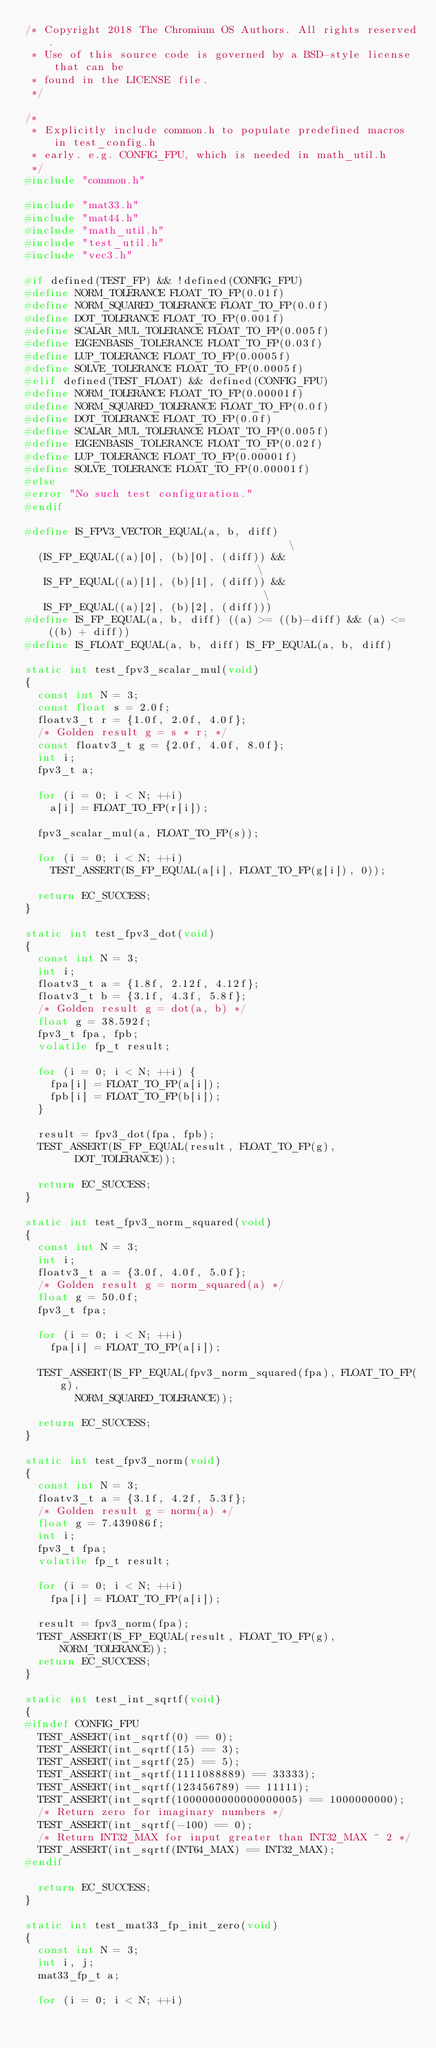Convert code to text. <code><loc_0><loc_0><loc_500><loc_500><_C_>/* Copyright 2018 The Chromium OS Authors. All rights reserved.
 * Use of this source code is governed by a BSD-style license that can be
 * found in the LICENSE file.
 */

/*
 * Explicitly include common.h to populate predefined macros in test_config.h
 * early. e.g. CONFIG_FPU, which is needed in math_util.h
 */
#include "common.h"

#include "mat33.h"
#include "mat44.h"
#include "math_util.h"
#include "test_util.h"
#include "vec3.h"

#if defined(TEST_FP) && !defined(CONFIG_FPU)
#define NORM_TOLERANCE FLOAT_TO_FP(0.01f)
#define NORM_SQUARED_TOLERANCE FLOAT_TO_FP(0.0f)
#define DOT_TOLERANCE FLOAT_TO_FP(0.001f)
#define SCALAR_MUL_TOLERANCE FLOAT_TO_FP(0.005f)
#define EIGENBASIS_TOLERANCE FLOAT_TO_FP(0.03f)
#define LUP_TOLERANCE FLOAT_TO_FP(0.0005f)
#define SOLVE_TOLERANCE FLOAT_TO_FP(0.0005f)
#elif defined(TEST_FLOAT) && defined(CONFIG_FPU)
#define NORM_TOLERANCE FLOAT_TO_FP(0.00001f)
#define NORM_SQUARED_TOLERANCE FLOAT_TO_FP(0.0f)
#define DOT_TOLERANCE FLOAT_TO_FP(0.0f)
#define SCALAR_MUL_TOLERANCE FLOAT_TO_FP(0.005f)
#define EIGENBASIS_TOLERANCE FLOAT_TO_FP(0.02f)
#define LUP_TOLERANCE FLOAT_TO_FP(0.00001f)
#define SOLVE_TOLERANCE FLOAT_TO_FP(0.00001f)
#else
#error "No such test configuration."
#endif

#define IS_FPV3_VECTOR_EQUAL(a, b, diff)                                       \
	(IS_FP_EQUAL((a)[0], (b)[0], (diff)) &&                                \
	 IS_FP_EQUAL((a)[1], (b)[1], (diff)) &&                                \
	 IS_FP_EQUAL((a)[2], (b)[2], (diff)))
#define IS_FP_EQUAL(a, b, diff) ((a) >= ((b)-diff) && (a) <= ((b) + diff))
#define IS_FLOAT_EQUAL(a, b, diff) IS_FP_EQUAL(a, b, diff)

static int test_fpv3_scalar_mul(void)
{
	const int N = 3;
	const float s = 2.0f;
	floatv3_t r = {1.0f, 2.0f, 4.0f};
	/* Golden result g = s * r; */
	const floatv3_t g = {2.0f, 4.0f, 8.0f};
	int i;
	fpv3_t a;

	for (i = 0; i < N; ++i)
		a[i] = FLOAT_TO_FP(r[i]);

	fpv3_scalar_mul(a, FLOAT_TO_FP(s));

	for (i = 0; i < N; ++i)
		TEST_ASSERT(IS_FP_EQUAL(a[i], FLOAT_TO_FP(g[i]), 0));

	return EC_SUCCESS;
}

static int test_fpv3_dot(void)
{
	const int N = 3;
	int i;
	floatv3_t a = {1.8f, 2.12f, 4.12f};
	floatv3_t b = {3.1f, 4.3f, 5.8f};
	/* Golden result g = dot(a, b) */
	float g = 38.592f;
	fpv3_t fpa, fpb;
	volatile fp_t result;

	for (i = 0; i < N; ++i) {
		fpa[i] = FLOAT_TO_FP(a[i]);
		fpb[i] = FLOAT_TO_FP(b[i]);
	}

	result = fpv3_dot(fpa, fpb);
	TEST_ASSERT(IS_FP_EQUAL(result, FLOAT_TO_FP(g),
				DOT_TOLERANCE));

	return EC_SUCCESS;
}

static int test_fpv3_norm_squared(void)
{
	const int N = 3;
	int i;
	floatv3_t a = {3.0f, 4.0f, 5.0f};
	/* Golden result g = norm_squared(a) */
	float g = 50.0f;
	fpv3_t fpa;

	for (i = 0; i < N; ++i)
		fpa[i] = FLOAT_TO_FP(a[i]);

	TEST_ASSERT(IS_FP_EQUAL(fpv3_norm_squared(fpa), FLOAT_TO_FP(g),
				NORM_SQUARED_TOLERANCE));

	return EC_SUCCESS;
}

static int test_fpv3_norm(void)
{
	const int N = 3;
	floatv3_t a = {3.1f, 4.2f, 5.3f};
	/* Golden result g = norm(a) */
	float g = 7.439086f;
	int i;
	fpv3_t fpa;
	volatile fp_t result;

	for (i = 0; i < N; ++i)
		fpa[i] = FLOAT_TO_FP(a[i]);

	result = fpv3_norm(fpa);
	TEST_ASSERT(IS_FP_EQUAL(result, FLOAT_TO_FP(g), NORM_TOLERANCE));
	return EC_SUCCESS;
}

static int test_int_sqrtf(void)
{
#ifndef CONFIG_FPU
	TEST_ASSERT(int_sqrtf(0) == 0);
	TEST_ASSERT(int_sqrtf(15) == 3);
	TEST_ASSERT(int_sqrtf(25) == 5);
	TEST_ASSERT(int_sqrtf(1111088889) == 33333);
	TEST_ASSERT(int_sqrtf(123456789) == 11111);
	TEST_ASSERT(int_sqrtf(1000000000000000005) == 1000000000);
	/* Return zero for imaginary numbers */
	TEST_ASSERT(int_sqrtf(-100) == 0);
	/* Return INT32_MAX for input greater than INT32_MAX ^ 2 */
	TEST_ASSERT(int_sqrtf(INT64_MAX) == INT32_MAX);
#endif

	return EC_SUCCESS;
}

static int test_mat33_fp_init_zero(void)
{
	const int N = 3;
	int i, j;
	mat33_fp_t a;

	for (i = 0; i < N; ++i)</code> 